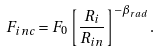Convert formula to latex. <formula><loc_0><loc_0><loc_500><loc_500>F _ { i n c } = F _ { 0 } \left [ \frac { R _ { i } } { R _ { i n } } \right ] ^ { - \beta _ { r a d } } .</formula> 